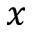Convert formula to latex. <formula><loc_0><loc_0><loc_500><loc_500>x</formula> 